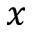Convert formula to latex. <formula><loc_0><loc_0><loc_500><loc_500>x</formula> 